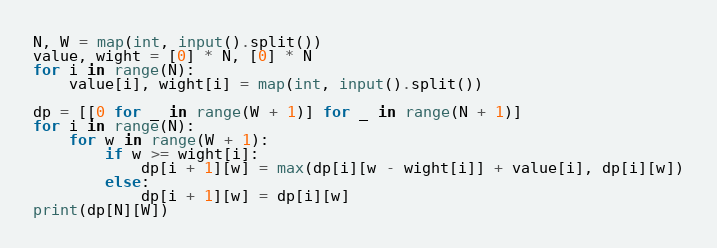Convert code to text. <code><loc_0><loc_0><loc_500><loc_500><_Python_>N, W = map(int, input().split())
value, wight = [0] * N, [0] * N
for i in range(N):
    value[i], wight[i] = map(int, input().split())

dp = [[0 for _ in range(W + 1)] for _ in range(N + 1)]
for i in range(N):
    for w in range(W + 1):
        if w >= wight[i]:
            dp[i + 1][w] = max(dp[i][w - wight[i]] + value[i], dp[i][w])
        else:
            dp[i + 1][w] = dp[i][w]
print(dp[N][W])
</code> 